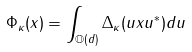<formula> <loc_0><loc_0><loc_500><loc_500>\Phi _ { \kappa } ( x ) = \int _ { \mathbb { O } ( d ) } \Delta _ { \kappa } ( u x u ^ { * } ) d u</formula> 